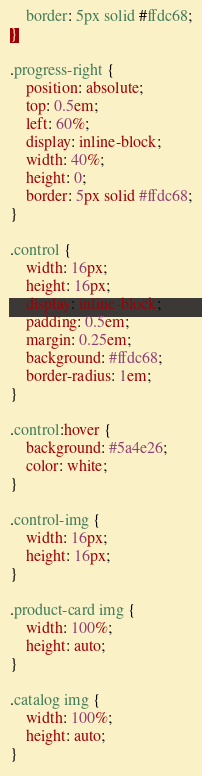Convert code to text. <code><loc_0><loc_0><loc_500><loc_500><_CSS_>    border: 5px solid #ffdc68;
}

.progress-right {
    position: absolute;
    top: 0.5em;
    left: 60%;
    display: inline-block;
    width: 40%;
    height: 0;
    border: 5px solid #ffdc68;
}

.control {
	width: 16px;
	height: 16px;
	display: inline-block;
    padding: 0.5em;
    margin: 0.25em;
    background: #ffdc68;
    border-radius: 1em;
}

.control:hover {
    background: #5a4e26;
    color: white;
}

.control-img {
	width: 16px;
	height: 16px;
}

.product-card img {
    width: 100%;
    height: auto;
}

.catalog img {
    width: 100%;
    height: auto;
}</code> 